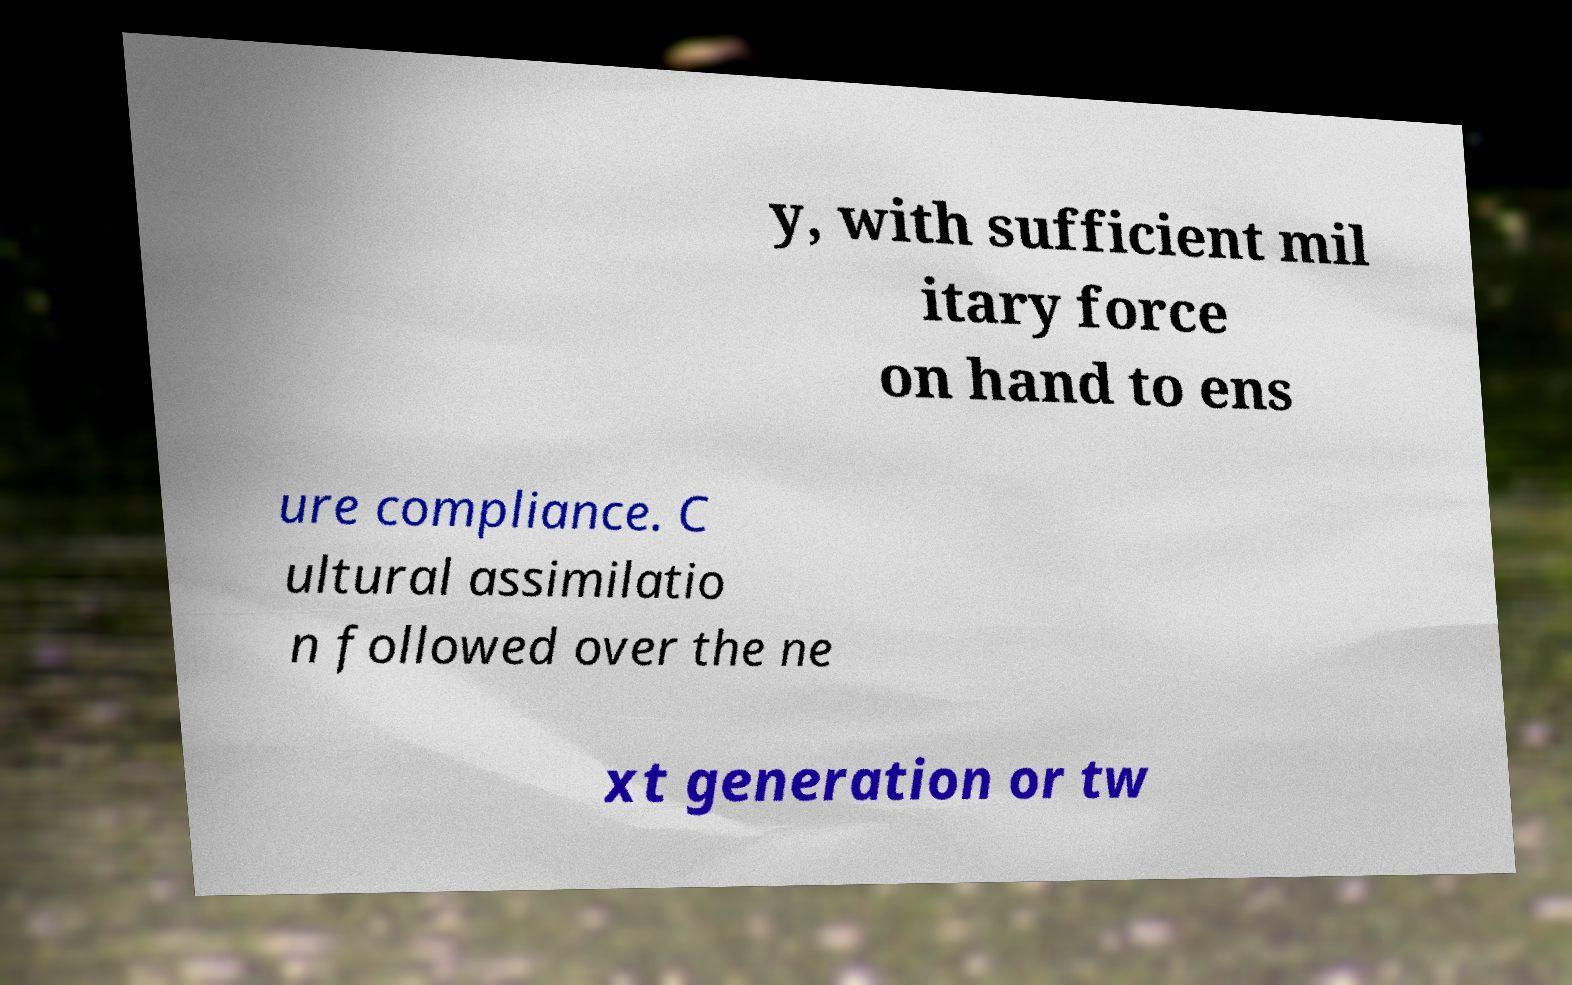What messages or text are displayed in this image? I need them in a readable, typed format. y, with sufficient mil itary force on hand to ens ure compliance. C ultural assimilatio n followed over the ne xt generation or tw 